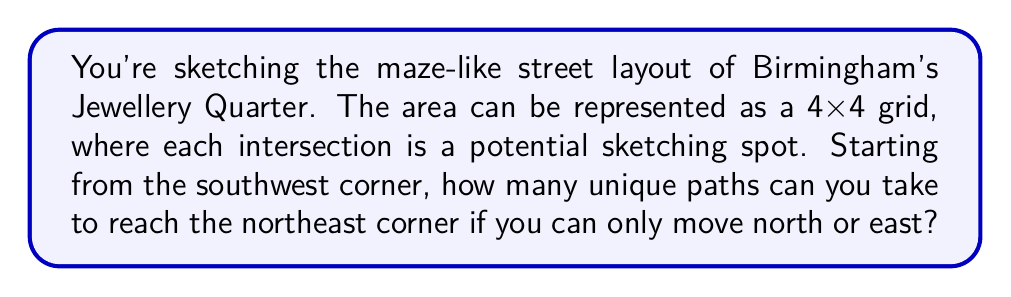What is the answer to this math problem? Let's approach this step-by-step:

1) First, observe that to get from the southwest corner to the northeast corner of a 4x4 grid, you must always move 3 steps east and 3 steps north, regardless of the path taken.

2) This problem is equivalent to choosing when to make the 3 east moves out of the total 6 moves (as the north moves will fill the other spots).

3) This is a combination problem. We need to calculate $\dbinom{6}{3}$, which represents the number of ways to choose 3 positions for east moves out of 6 total moves.

4) The formula for this combination is:

   $$\dbinom{6}{3} = \frac{6!}{3!(6-3)!} = \frac{6!}{3!3!}$$

5) Let's calculate this:
   
   $$\frac{6 * 5 * 4 * 3!}{(3 * 2 * 1)(3 * 2 * 1)} = \frac{120}{6} = 20$$

6) Therefore, there are 20 unique paths from the southwest corner to the northeast corner.

This result can be verified using Pascal's triangle or by drawing out all possible paths on the grid.
Answer: 20 paths 